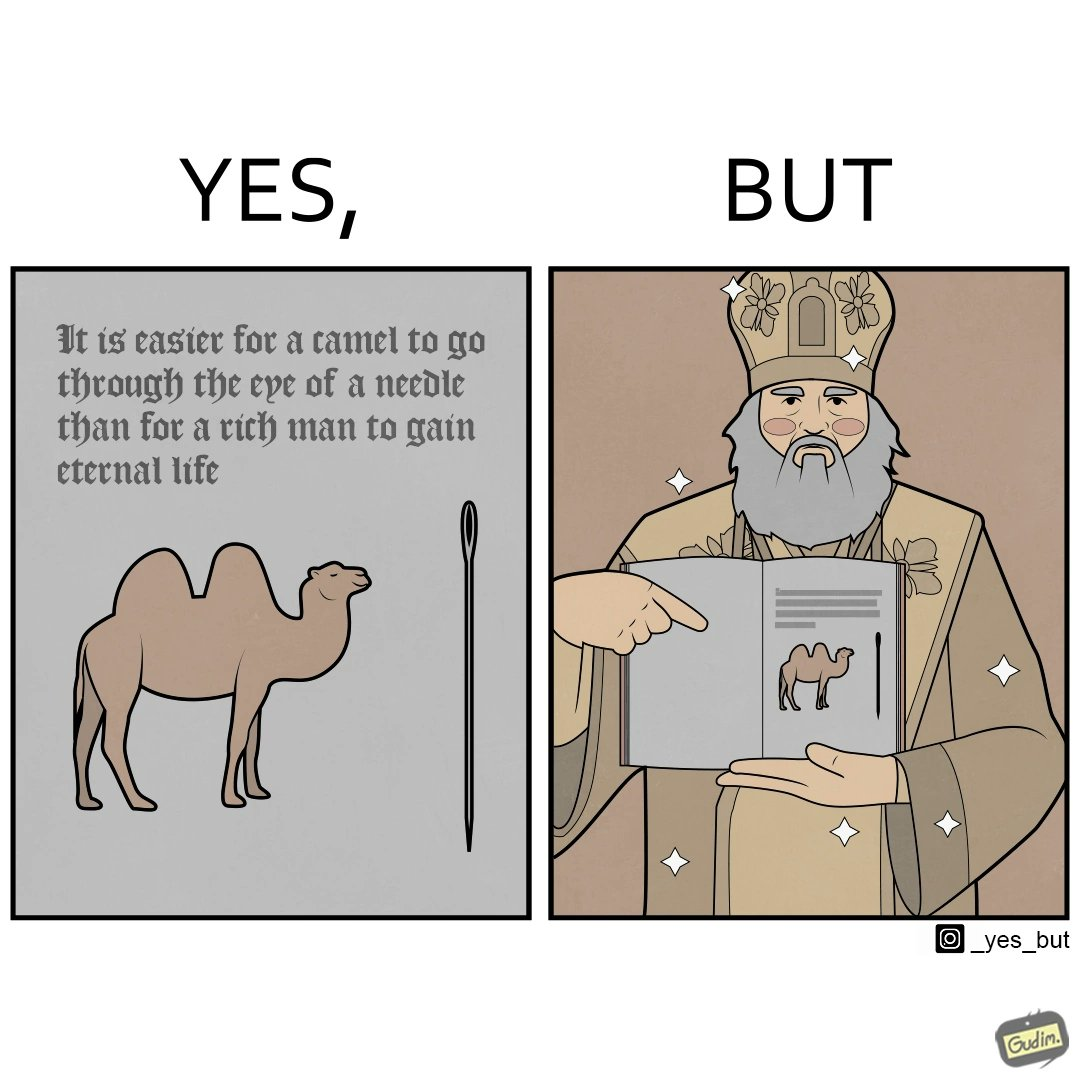Describe the contrast between the left and right parts of this image. In the left part of the image: a bactrian camel(two humped camel) is seen with a needle of its height in front of it and a quote written above the image In the right part of the image: a saintly old man is shown holding some poster with some writings on it with a photo of a bactrian camel(two humped camel) 